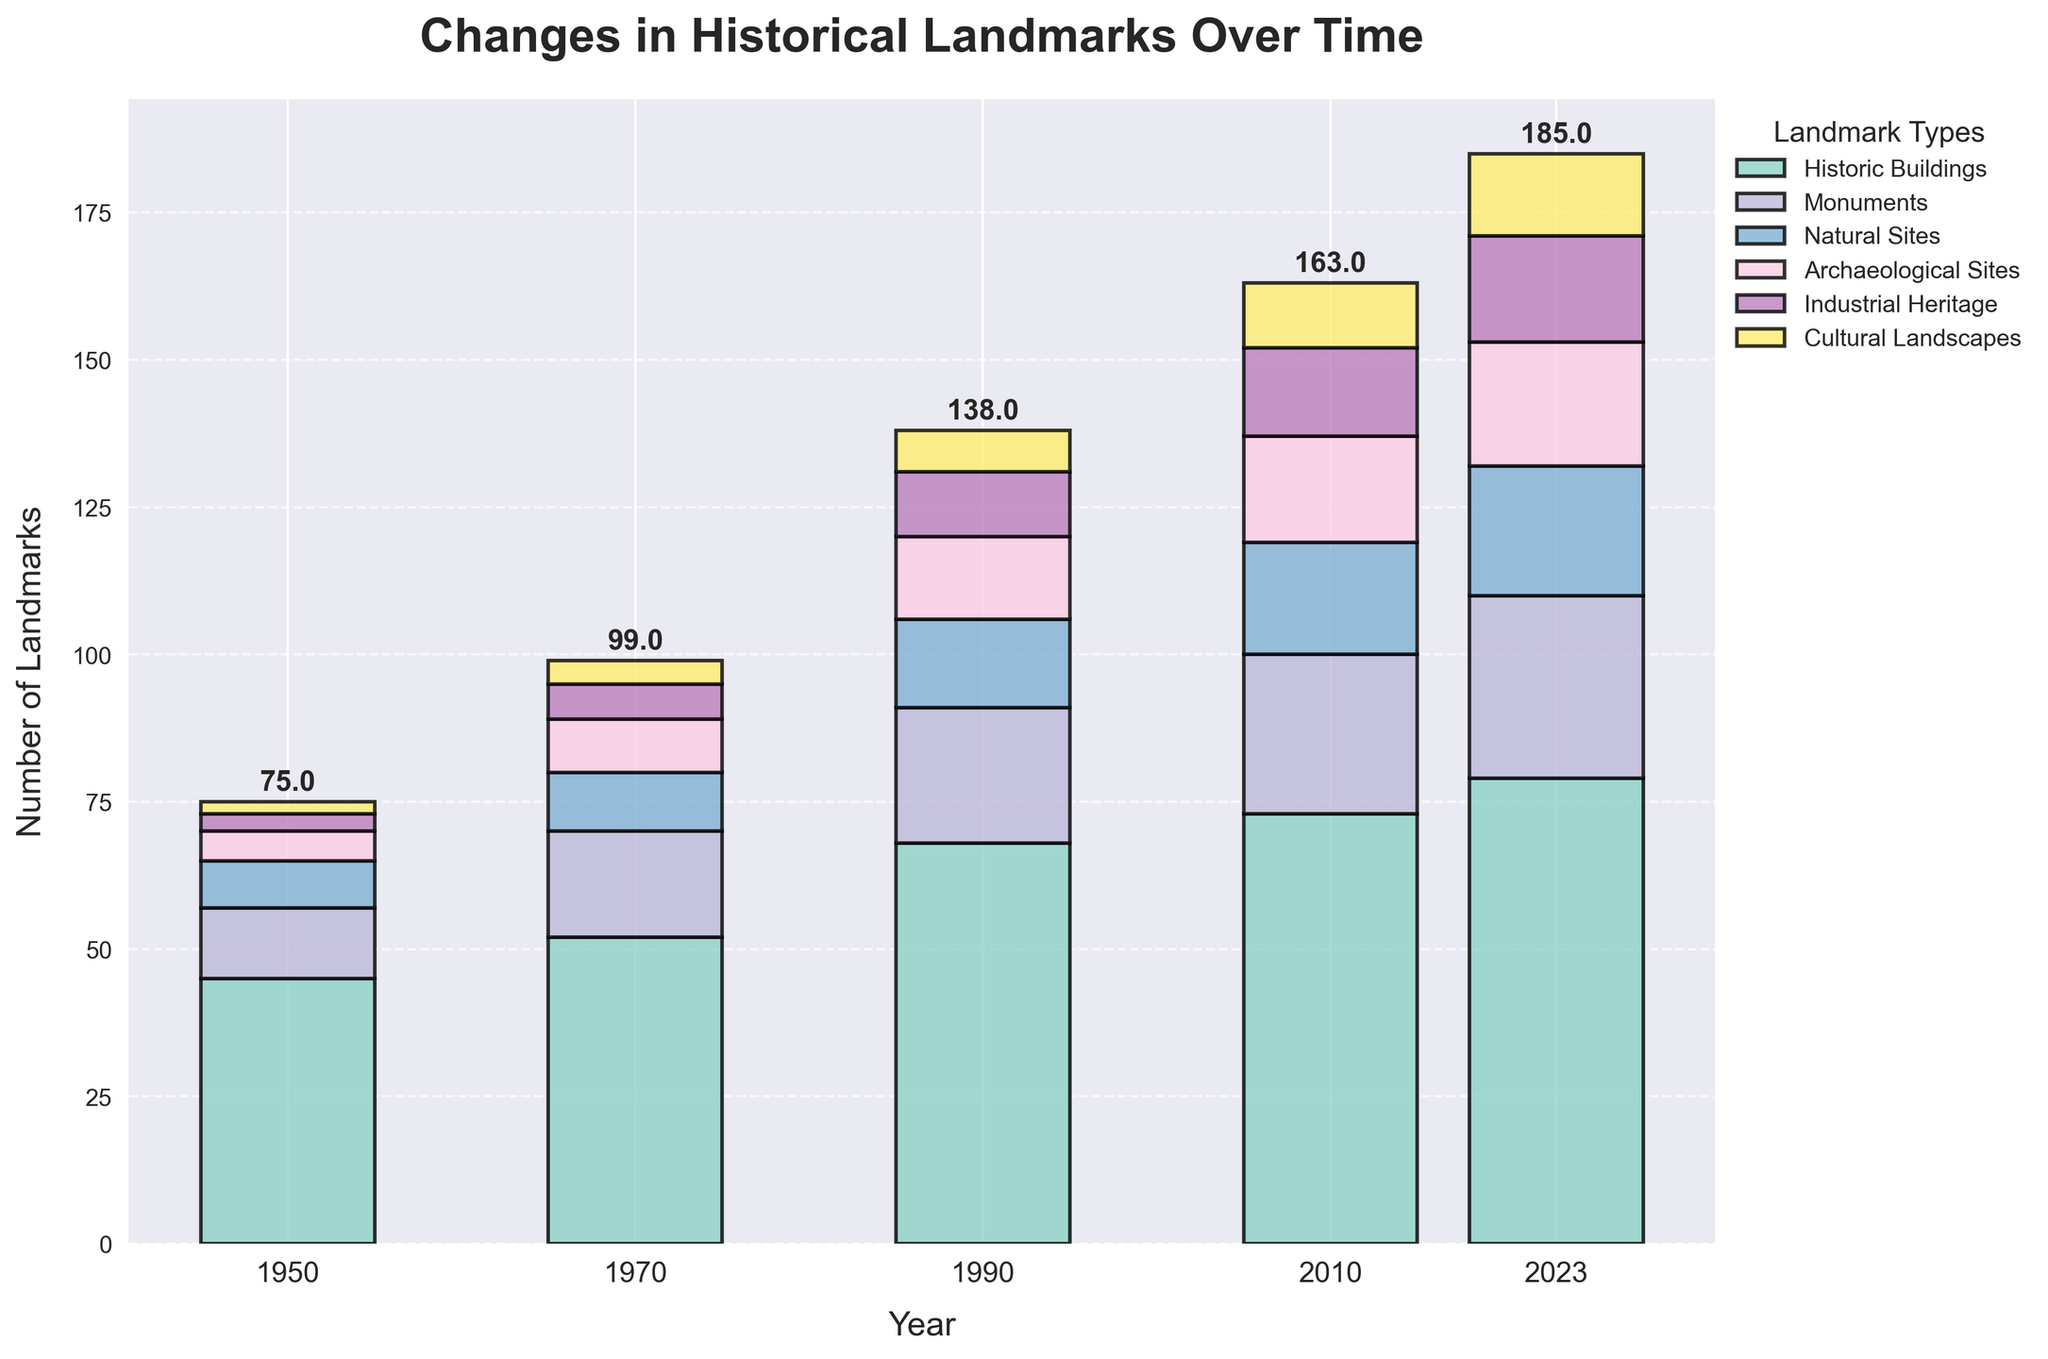what is the title of the chart? The title is typically located at the top of the figure and provides a brief summary of the content. In this case, it reads "Changes in Historical Landmarks Over Time."
Answer: Changes in Historical Landmarks Over Time How many categories of landmarks are represented in the chart? To find the number of categories of landmarks, we look at the legend. Each different color represents a different category of landmarks. The chart's legend contains six distinct types.
Answer: 6 What category had the highest number of landmarks in 2023? In 2023, we compare the heights of the different colored segments on top of each other. The highest section here is the yellow segment which represents 'Historic Buildings'.
Answer: Historic Buildings What is the difference in the number of monuments between 1950 and 2010? To find the difference, we look at the number of monuments in 1950 and then in 2010. In 1950 the number is 12 and in 2010 it is 27. Subtracting the former from the latter gives us 15.
Answer: 15 Which category showed the greatest increase from 1950 to 2023? By comparing the difference in tile height at 1950 versus 2023 for each category, we determine the 'Historic Buildings' category has the greatest increase, from 45 to 79.
Answer: Historic Buildings How many total landmarks were there in 1990? To determine the cumulative number of landmarks in 1990, we add the number for each category in 1990. Summing them up: 68 (Historic Buildings) + 23 (Monuments) + 15 (Natural Sites) + 14 (Archaeological Sites) + 11 (Industrial Heritage) + 7 (Cultural Landscapes) = 138.
Answer: 138 Which category had the smallest increase from 1990 to 2023? Comparing the differences in the number of landmarks from 1990 to 2023 across all categories, we find 'Natural Sites' increased by the least, from 15 to 22, which is an increase of 7.
Answer: Natural Sites What can be observed about the trend of cultural landscapes over time? Observing the height of the segment representing 'Cultural Landscapes' across all years, it consistently increases: from 2 in 1950 up to 14 in 2023. This shows a continuous rise in the number of cultural landscapes.
Answer: Continuous rise How many more landmarks were there in 2023 compared to 1950 for cultural landscapes? To find this difference, we subtract the number of cultural landscapes in 1950 (2) from the number in 2023 (14). Therefore, 14 - 2 = 12.
Answer: 12 